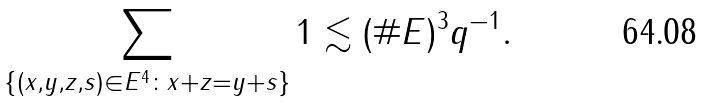Convert formula to latex. <formula><loc_0><loc_0><loc_500><loc_500>\sum _ { \{ ( x , y , z , s ) \in E ^ { 4 } \colon x + z = y + s \} } 1 \lesssim ( \# E ) ^ { 3 } q ^ { - 1 } .</formula> 